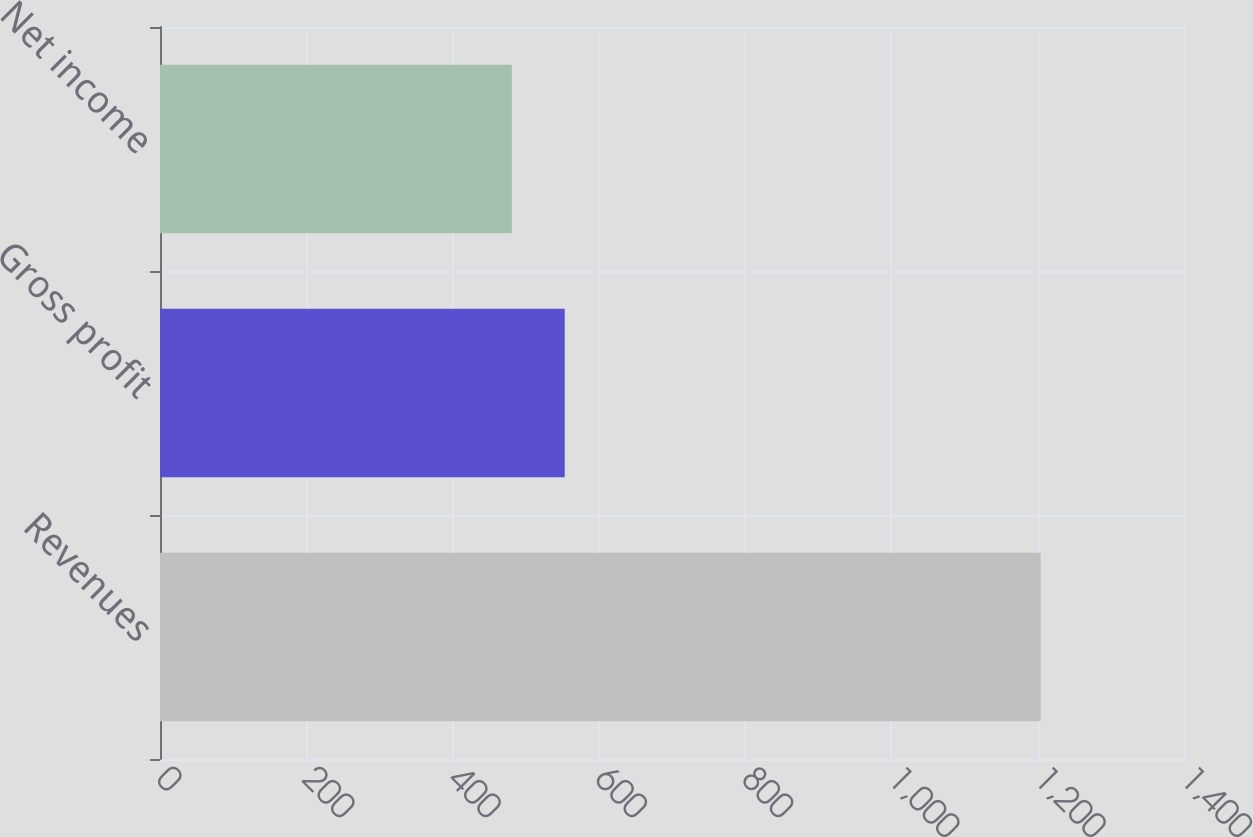Convert chart. <chart><loc_0><loc_0><loc_500><loc_500><bar_chart><fcel>Revenues<fcel>Gross profit<fcel>Net income<nl><fcel>1204<fcel>553.3<fcel>481<nl></chart> 